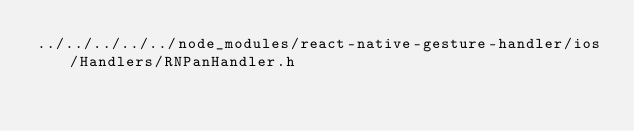Convert code to text. <code><loc_0><loc_0><loc_500><loc_500><_C_>../../../../../node_modules/react-native-gesture-handler/ios/Handlers/RNPanHandler.h</code> 